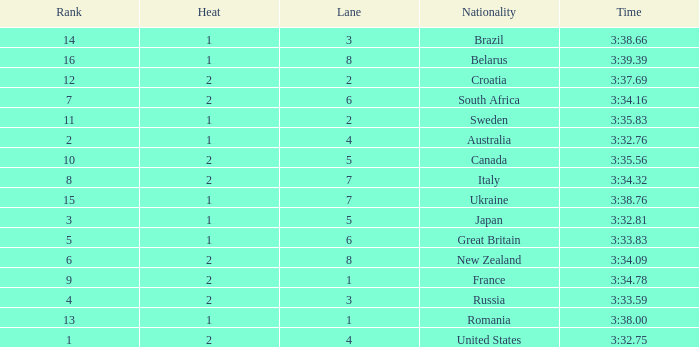Can you tell me the Time that has the Heat of 1, and the Lane of 2? 3:35.83. 